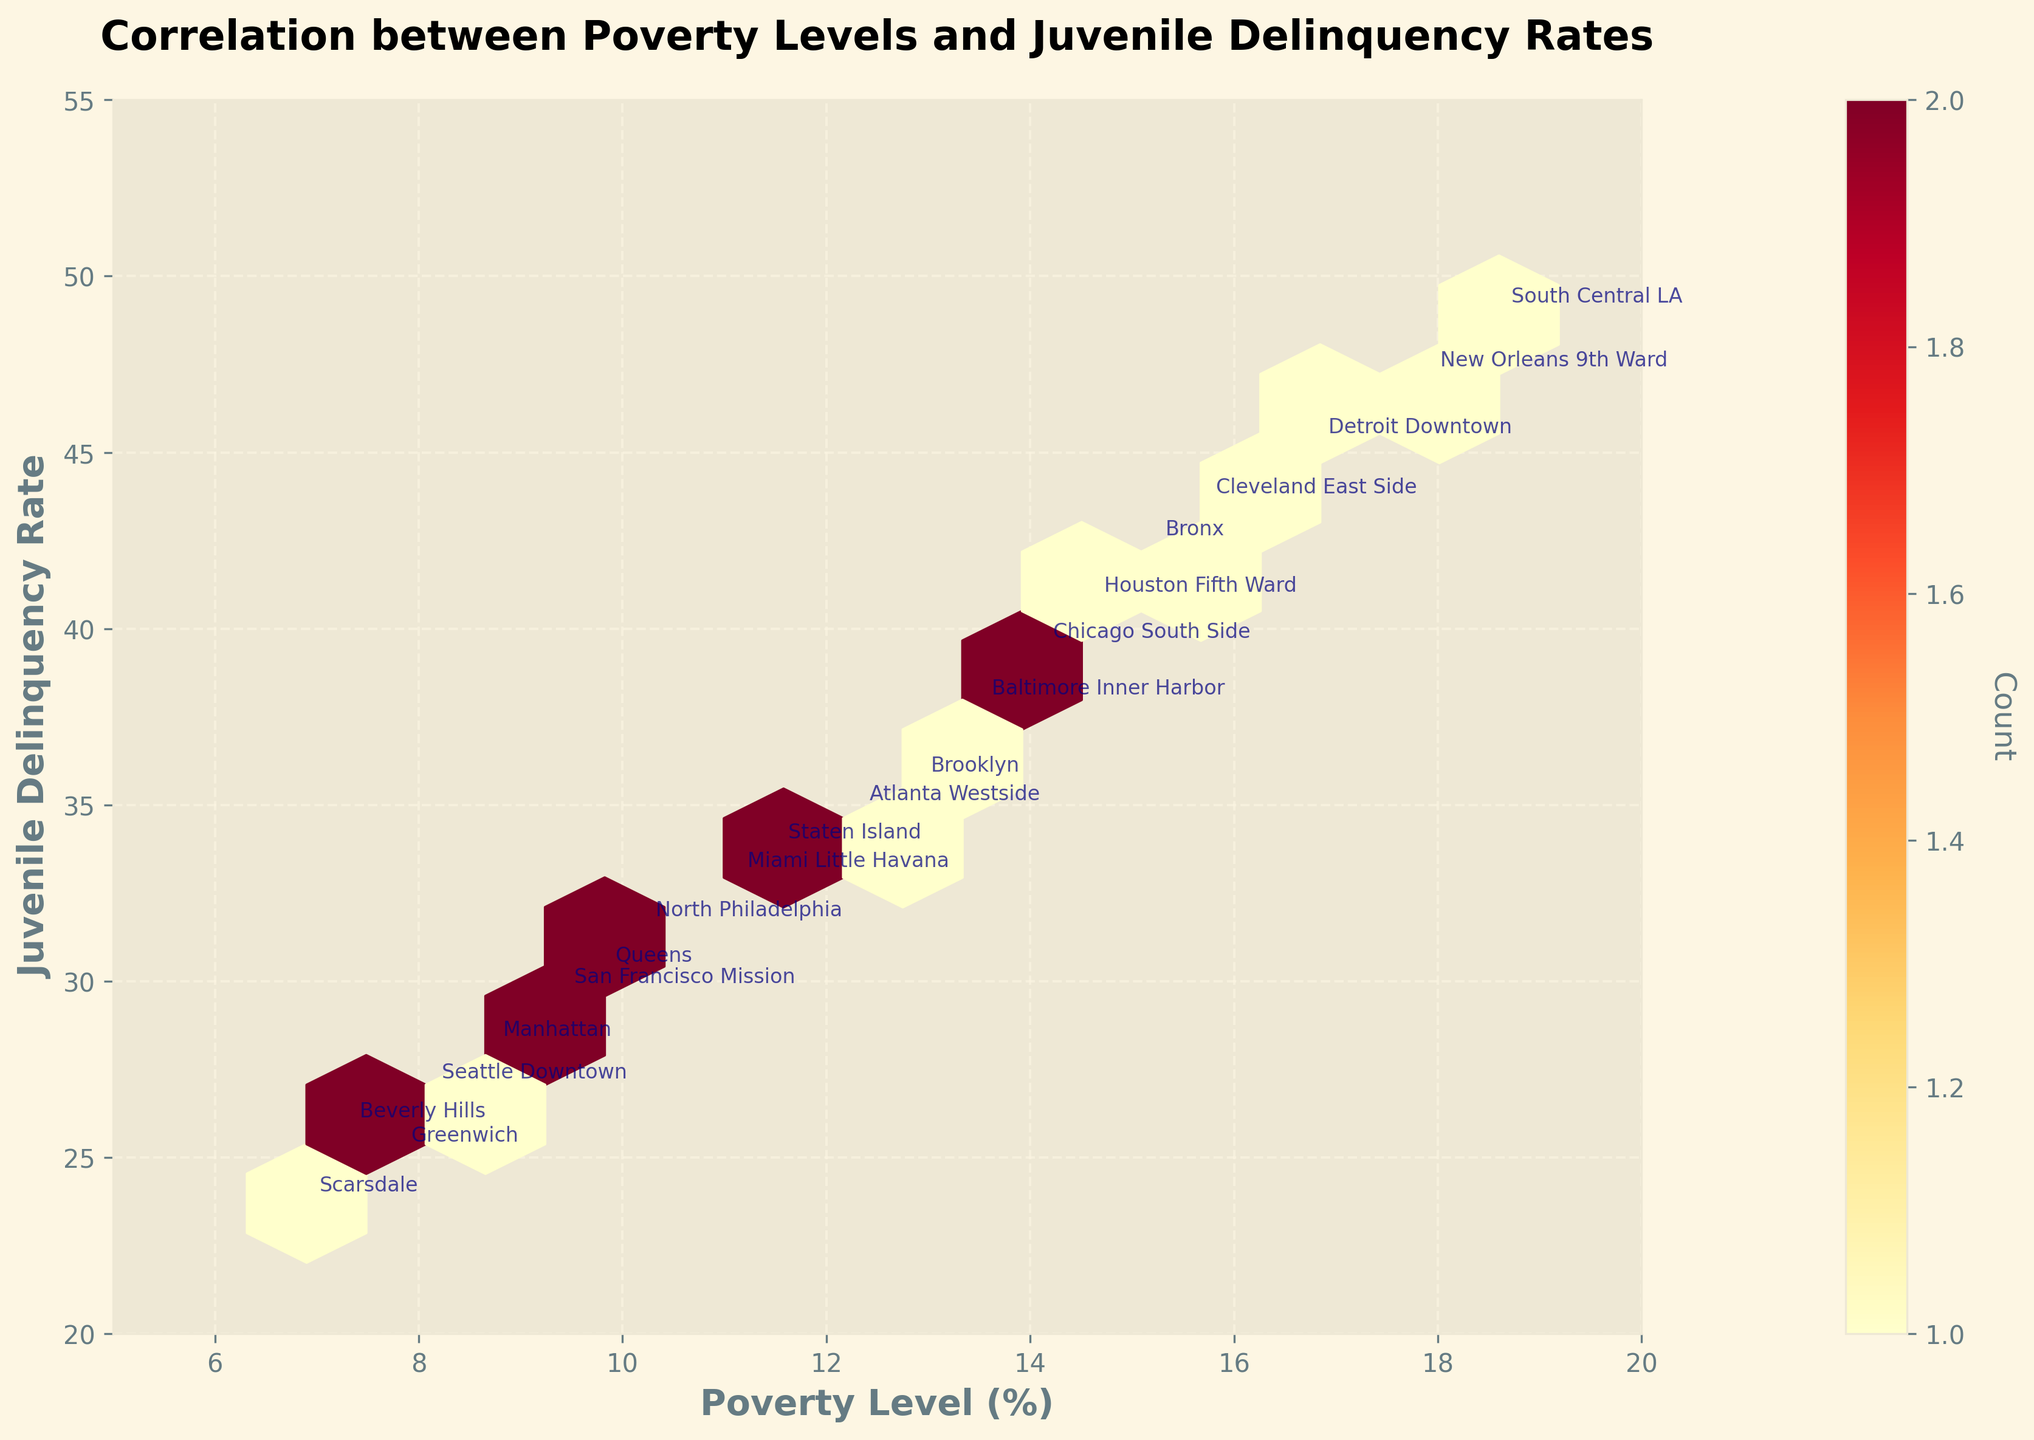What is the title of the graph? The title is located at the top-center of the graph, which provides a summary of what the graph represents.
Answer: Correlation between Poverty Levels and Juvenile Delinquency Rates What is the x-axis label? The x-axis label is located at the bottom of the graph and indicates what data is being represented on the horizontal scale.
Answer: Poverty Level (%) What is the range of the y-axis? The y-axis, which is vertical on the left side of the graph, is marked with its minimum and maximum values.
Answer: 20 to 55 How many data points fall into the highest density hexbin? Identify the color corresponding to the highest density in the colorbar, then locate the hexbin with that color on the plot, and check the count label on the colorbar.
Answer: The exact number can vary, but it is indicated by the colorbar label for the densest hex Which district has the highest juvenile delinquency rate? Look for the annotated district name with the highest value on the y-axis.
Answer: South Central LA What is the relationship between the poverty level and juvenile delinquency rate as shown in the plot? Observe the trend formed by the hexagonal bins and determine if there is an overall increase, decrease, or no change.
Answer: Positive correlation Which district falls close to a 10% poverty level and has a 30% juvenile delinquency rate? Check the approximate 10% mark on the x-axis, then find the closest district name annotated near the 30% mark on the y-axis.
Answer: Queens How do the juvenile delinquency rates compare between districts with around 15% poverty levels? Identify districts with about 15% on the x-axis and compare their positions on the y-axis for juvenile delinquency rates.
Answer: Bronx, Chicago South Side, Cleveland East Side, Houston Fifth Ward (varies slightly) On average, how does poverty level relate to the density of juvenile delinquency data points? Look at the color density of the hexes along the x-axis intervals and determine the general trend of density as poverty level changes.
Answer: Higher density in the middle range of poverty levels (around 10-15%) Which region has a lower poverty level and juvenile delinquency rate: Manhattan or Brooklyn? Identify the positions of Brooklyn and Manhattan annotations and compare their x (poverty) and y (delinquency) values.
Answer: Manhattan 